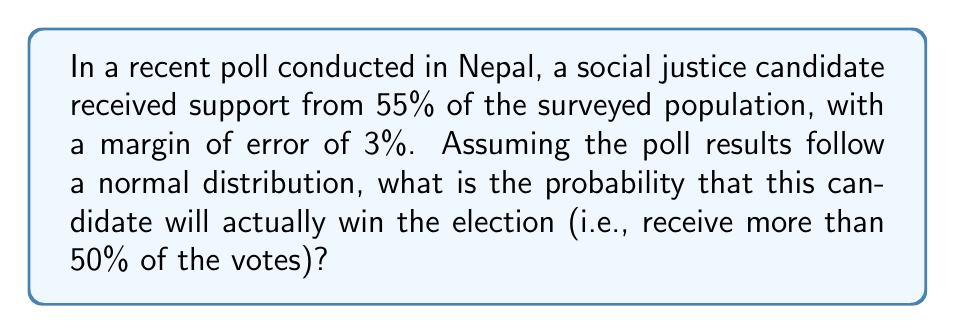Could you help me with this problem? To solve this problem, we need to use the properties of the normal distribution and the concept of z-scores. Let's break it down step-by-step:

1) The poll result is 55% with a margin of error of 3%. This means:
   $\mu = 0.55$ (mean)
   $\sigma = 0.03$ (standard deviation)

2) We want to find the probability that the actual result is greater than 50%. In other words, we need to find $P(X > 0.50)$ where $X$ is the actual vote percentage.

3) To use the standard normal distribution, we need to calculate the z-score for 50%:

   $$z = \frac{x - \mu}{\sigma} = \frac{0.50 - 0.55}{0.03} = -1.67$$

4) Now, we need to find $P(Z > -1.67)$ where $Z$ is the standard normal variable.

5) Using the standard normal distribution table or a calculator, we can find that:
   $P(Z < -1.67) \approx 0.0475$

6) Since we want $P(Z > -1.67)$, and the total probability is 1, we calculate:

   $$P(Z > -1.67) = 1 - P(Z < -1.67) = 1 - 0.0475 = 0.9525$$

Therefore, the probability that the candidate will actually win the election is approximately 0.9525 or 95.25%.
Answer: The probability that the social justice candidate will win the election is approximately 0.9525 or 95.25%. 